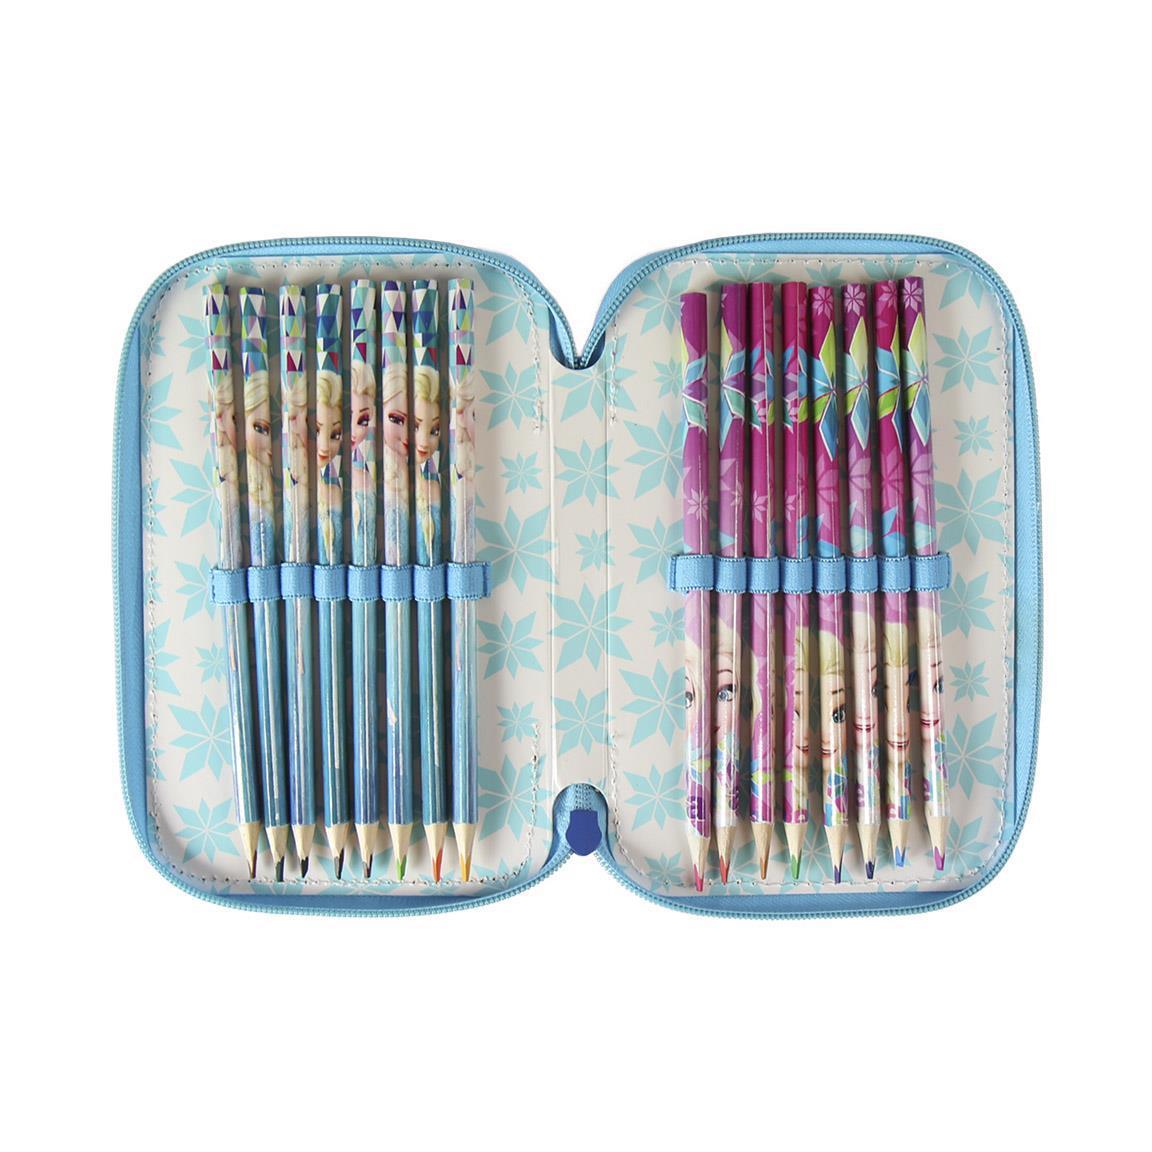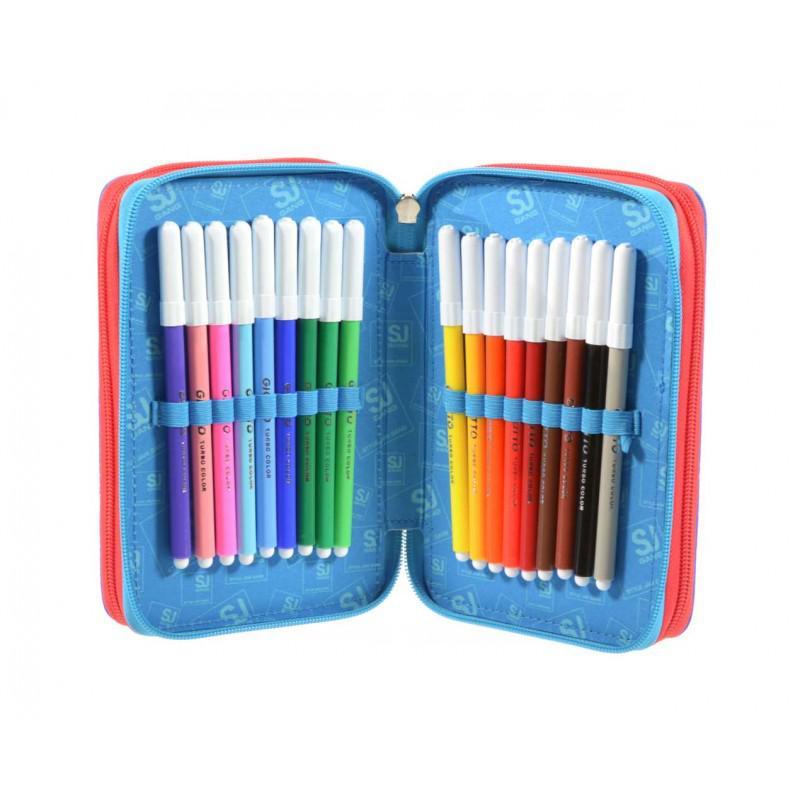The first image is the image on the left, the second image is the image on the right. For the images shown, is this caption "At least one of the pencil cases has a pencil sharpener fastened within." true? Answer yes or no. No. 